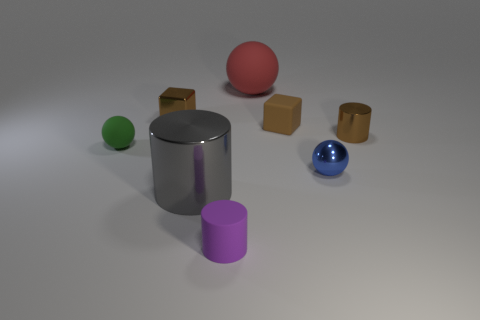Add 1 balls. How many objects exist? 9 Subtract all blocks. How many objects are left? 6 Add 3 big metallic objects. How many big metallic objects exist? 4 Subtract 0 blue cylinders. How many objects are left? 8 Subtract all small blue metallic objects. Subtract all large rubber spheres. How many objects are left? 6 Add 2 small rubber cylinders. How many small rubber cylinders are left? 3 